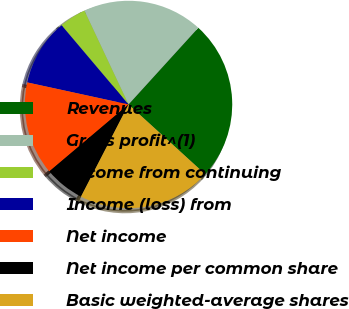Convert chart to OTSL. <chart><loc_0><loc_0><loc_500><loc_500><pie_chart><fcel>Revenues<fcel>Gross profit^(1)<fcel>Income from continuing<fcel>Income (loss) from<fcel>Net income<fcel>Net income per common share<fcel>Basic weighted-average shares<nl><fcel>25.0%<fcel>18.75%<fcel>4.17%<fcel>10.42%<fcel>14.58%<fcel>6.25%<fcel>20.83%<nl></chart> 